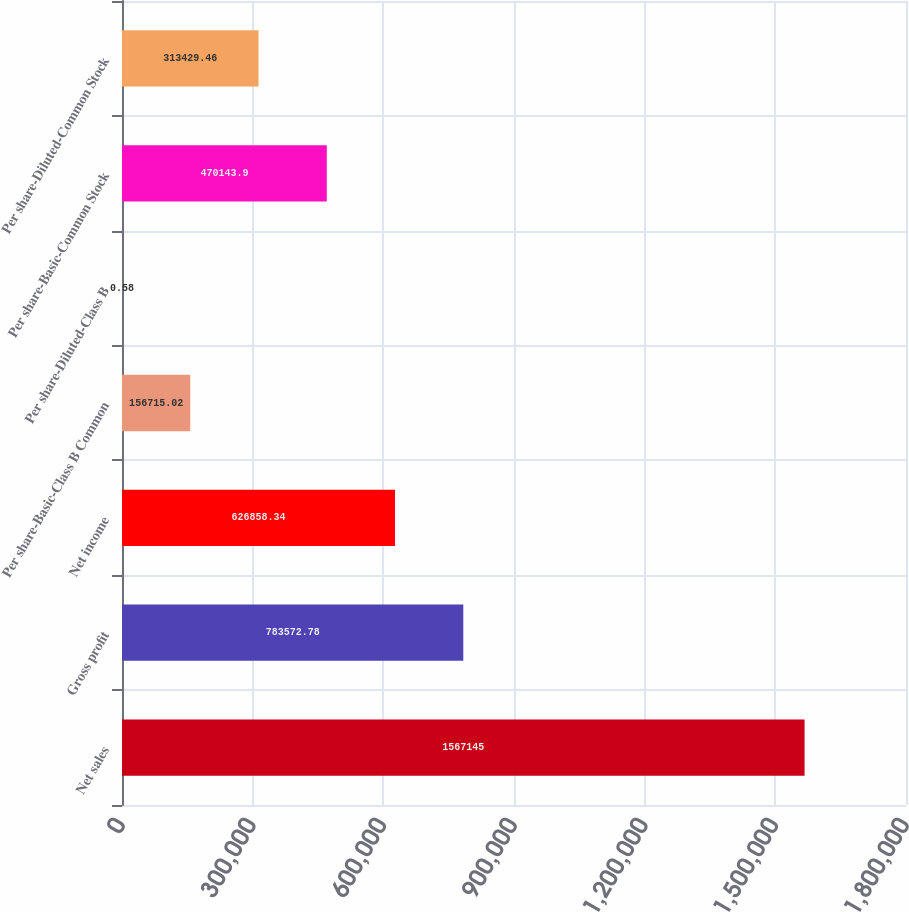Convert chart. <chart><loc_0><loc_0><loc_500><loc_500><bar_chart><fcel>Net sales<fcel>Gross profit<fcel>Net income<fcel>Per share-Basic-Class B Common<fcel>Per share-Diluted-Class B<fcel>Per share-Basic-Common Stock<fcel>Per share-Diluted-Common Stock<nl><fcel>1.56714e+06<fcel>783573<fcel>626858<fcel>156715<fcel>0.58<fcel>470144<fcel>313429<nl></chart> 